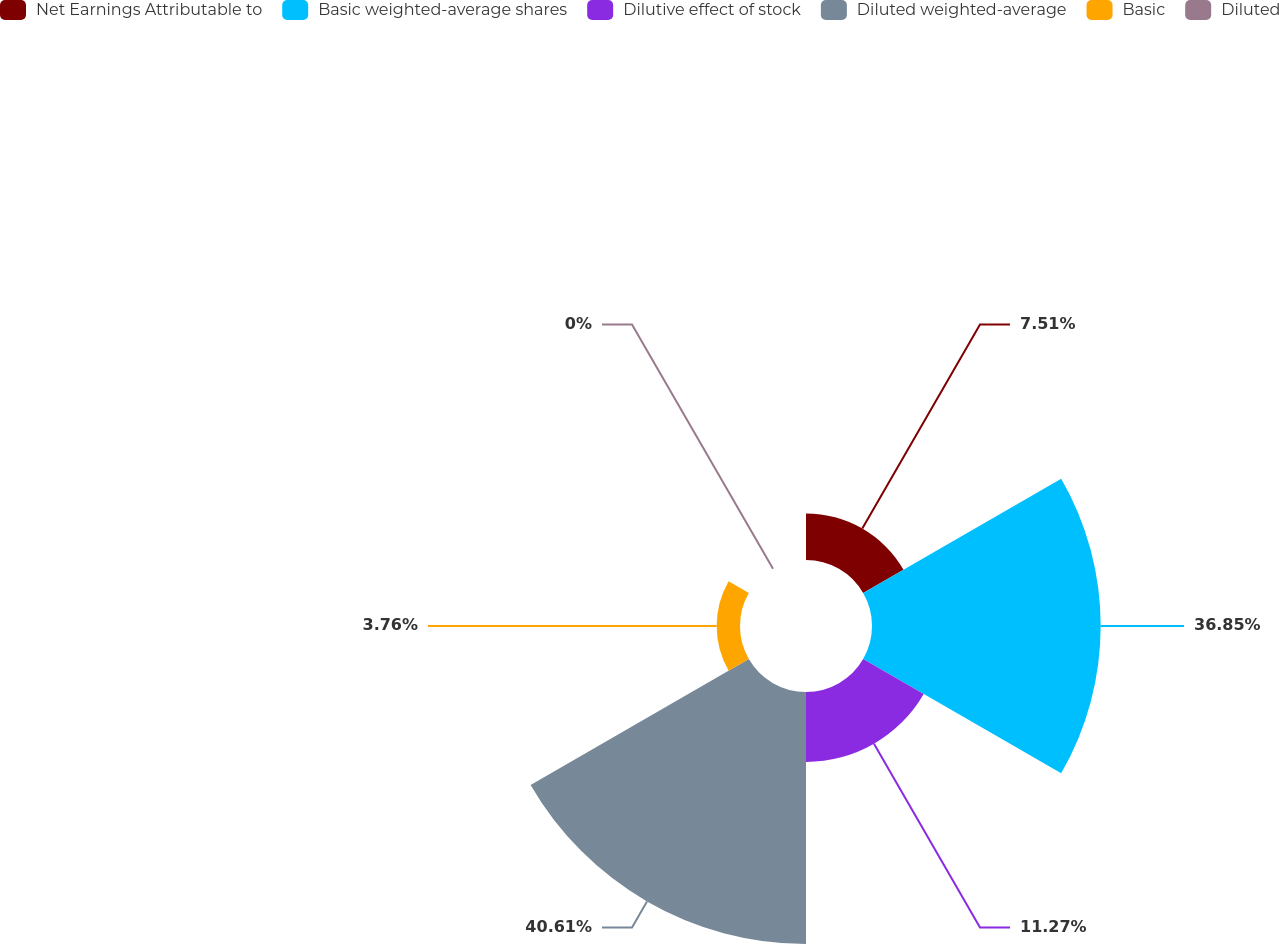Convert chart. <chart><loc_0><loc_0><loc_500><loc_500><pie_chart><fcel>Net Earnings Attributable to<fcel>Basic weighted-average shares<fcel>Dilutive effect of stock<fcel>Diluted weighted-average<fcel>Basic<fcel>Diluted<nl><fcel>7.51%<fcel>36.85%<fcel>11.27%<fcel>40.61%<fcel>3.76%<fcel>0.0%<nl></chart> 